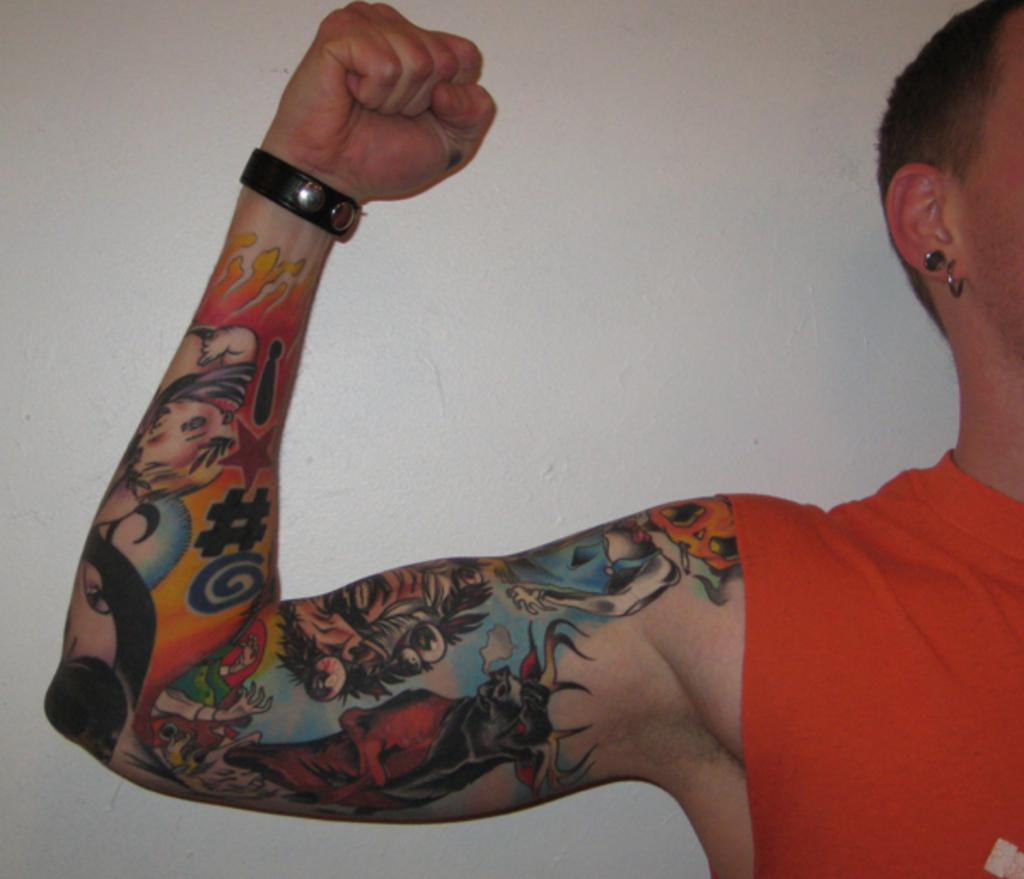Who is the main subject in the image? There is a man in the image. What is the man wearing? The man is wearing a band. Are there any visible markings or designs on the man's body? Yes, the man has a tattoo on his hand. What type of game is the man playing in the image? There is no game present in the image; it only features a man wearing a band and having a tattoo on his hand. Can you see any cords or wires connected to the man in the image? There are no cords or wires visible in the image. 